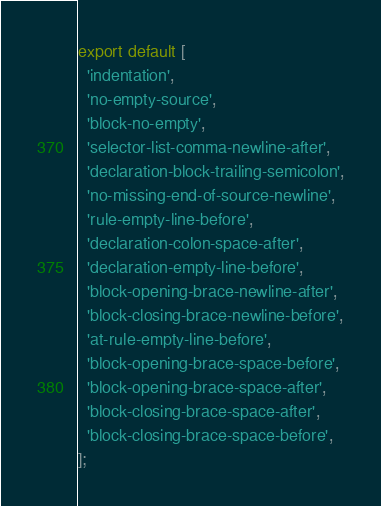Convert code to text. <code><loc_0><loc_0><loc_500><loc_500><_JavaScript_>export default [
  'indentation',
  'no-empty-source',
  'block-no-empty',
  'selector-list-comma-newline-after',
  'declaration-block-trailing-semicolon',
  'no-missing-end-of-source-newline',
  'rule-empty-line-before',
  'declaration-colon-space-after',
  'declaration-empty-line-before',
  'block-opening-brace-newline-after',
  'block-closing-brace-newline-before',
  'at-rule-empty-line-before',
  'block-opening-brace-space-before',
  'block-opening-brace-space-after',
  'block-closing-brace-space-after',
  'block-closing-brace-space-before',
];
</code> 